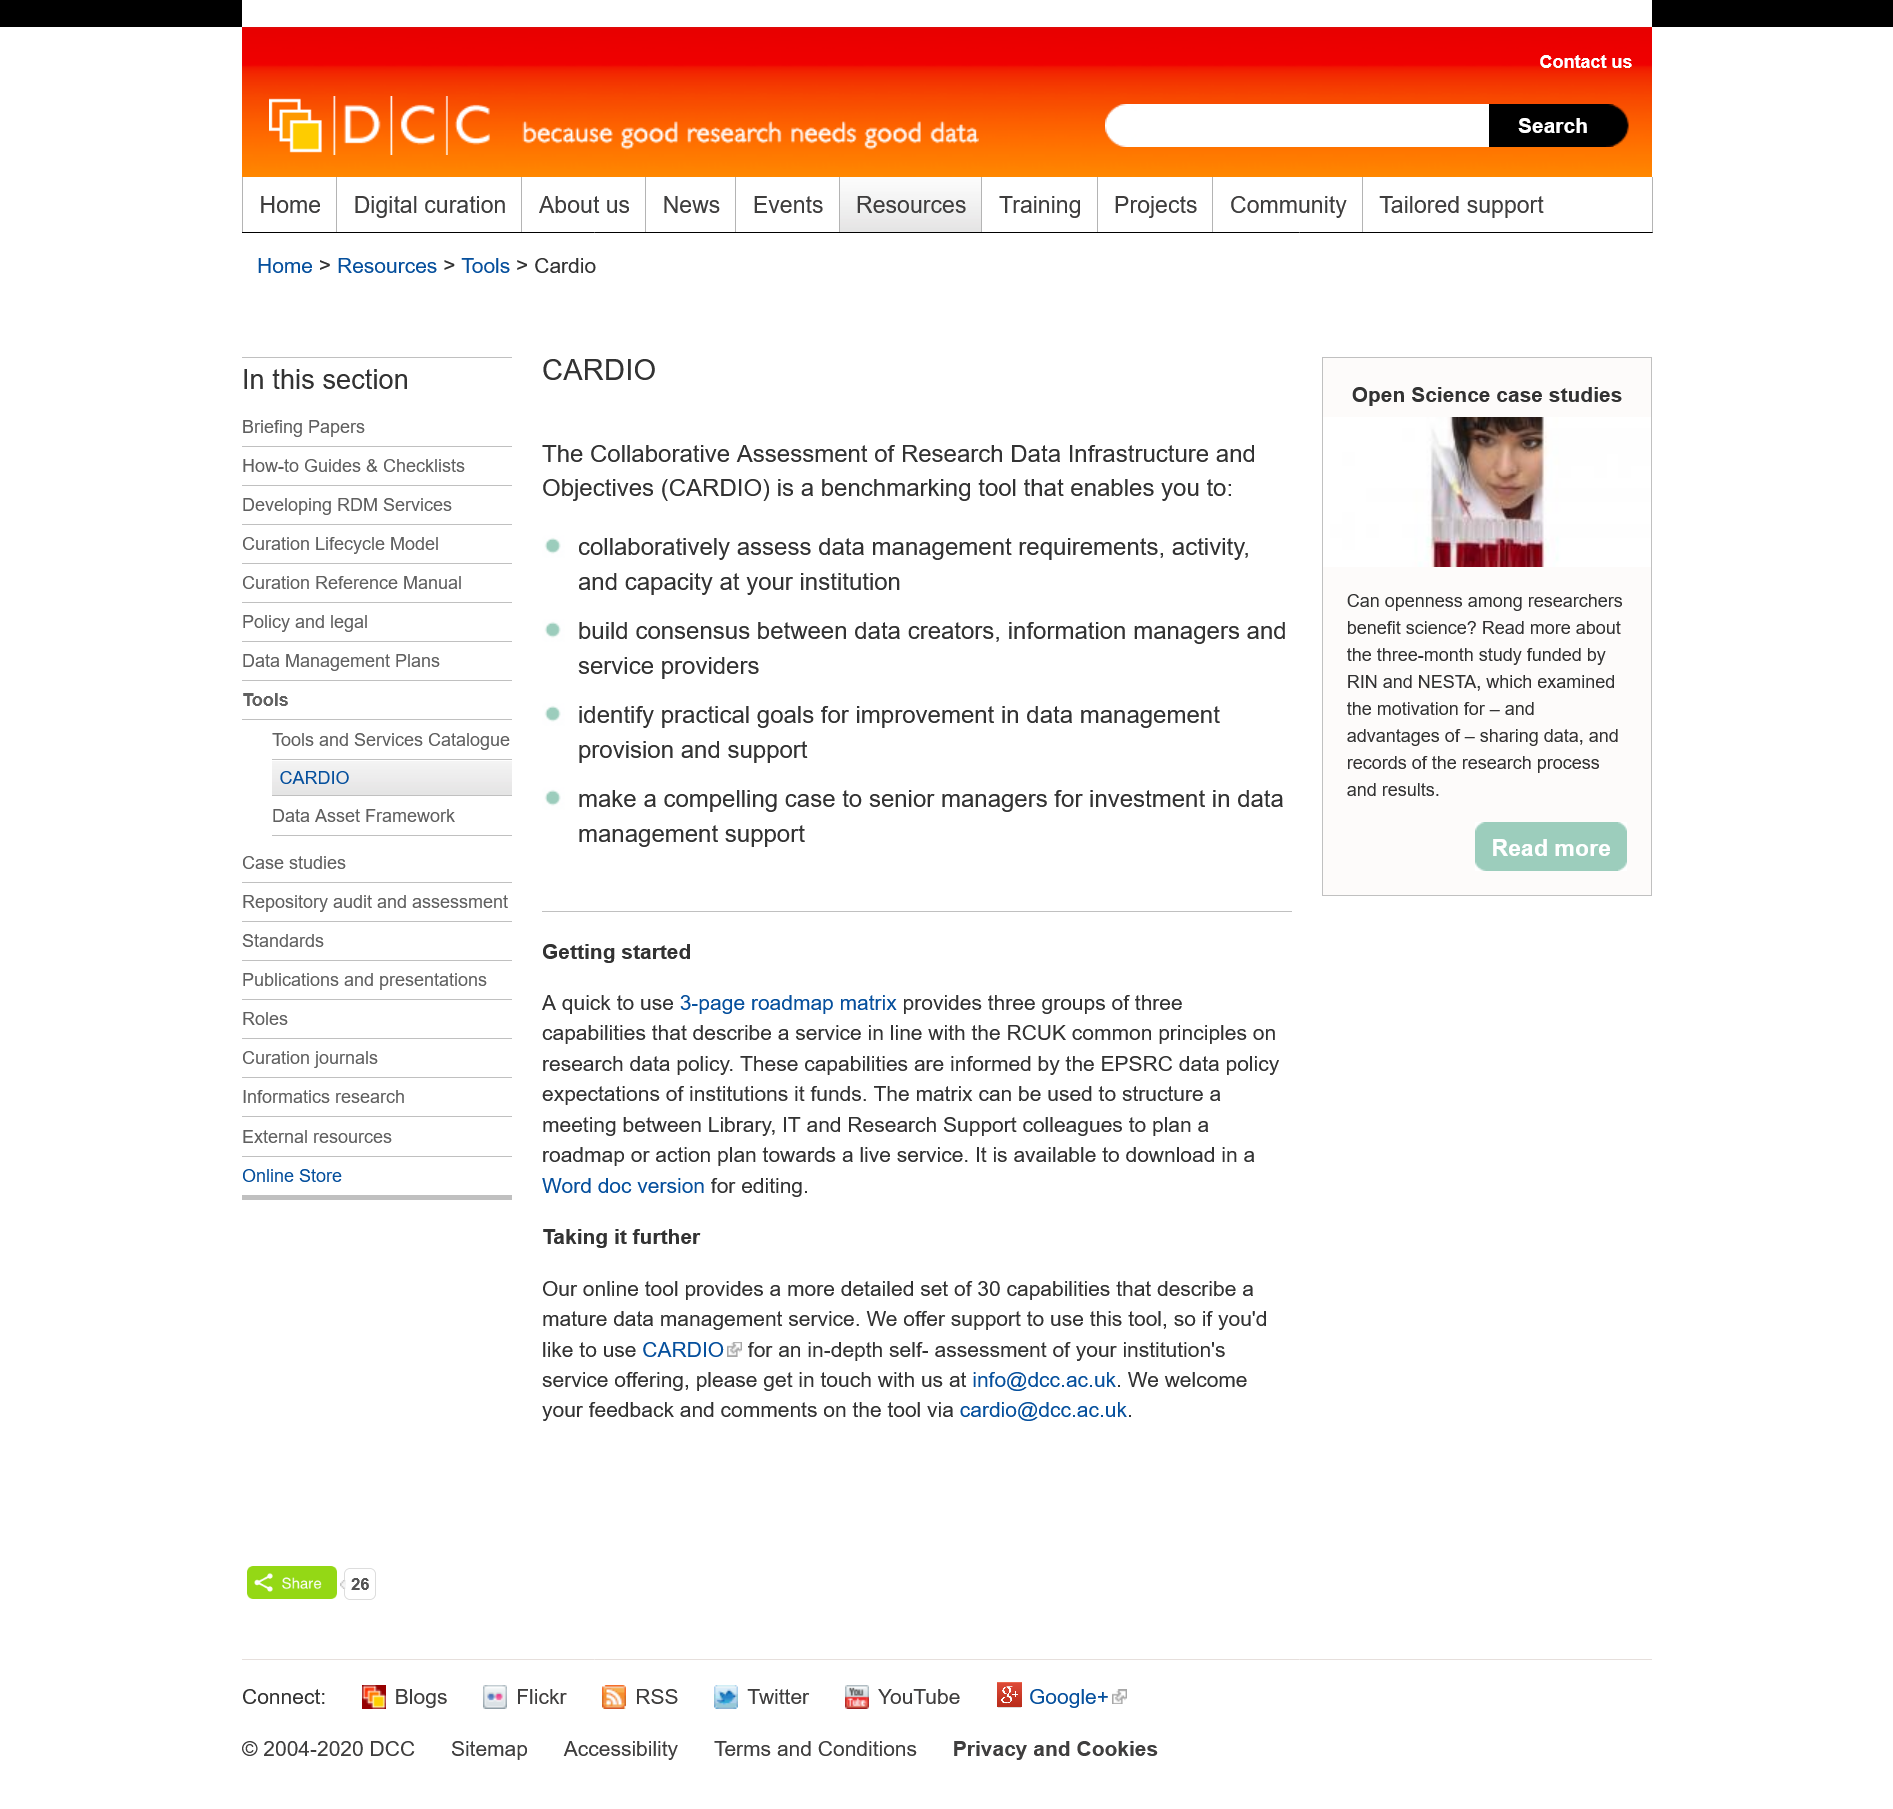Give some essential details in this illustration. The matrix can be utilized to organize a meeting between Library, IT, and Research Support colleagues, providing a structured framework for effective collaboration and decision-making. The purpose of the matrix is to formulate a roadmap or action plan for the development and implementation of a live service. The contact for feedback and comments on the tool is cardio@dcc.ac.uk. 